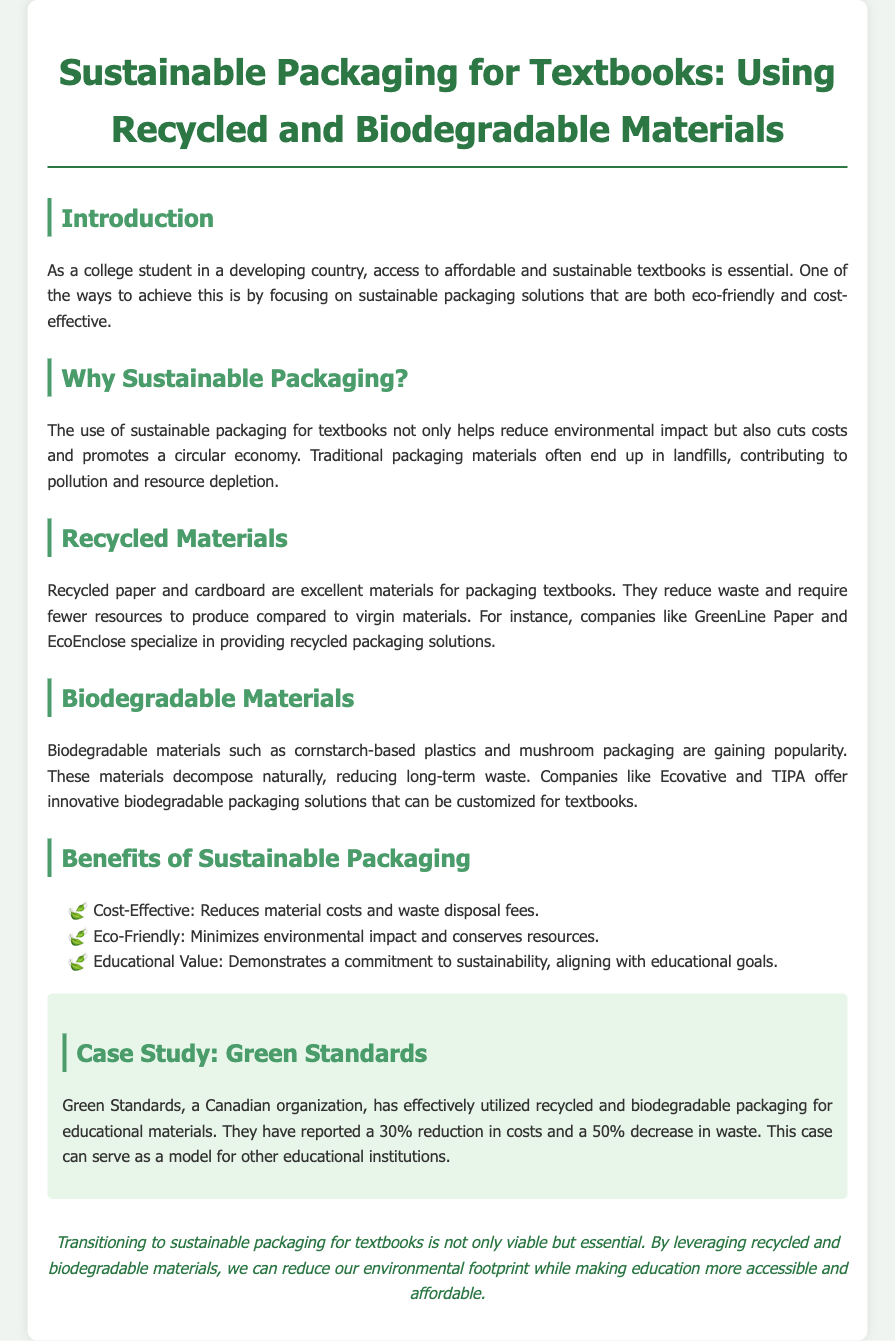What is the focus of the document? The document centers on sustainable packaging for textbooks, specifically using recycled and biodegradable materials.
Answer: Sustainable packaging for textbooks What is a major reason for using sustainable packaging? The document states that sustainable packaging helps reduce environmental impact and promotes a circular economy.
Answer: Reduce environmental impact Which company specializes in recycled packaging solutions? GreenLine Paper is mentioned as a company specializing in recycled packaging solutions.
Answer: GreenLine Paper What percentage reduction in costs did Green Standards report? Green Standards reported a 30% reduction in costs by utilizing sustainable packaging.
Answer: 30% What type of biodegradable material is gaining popularity? Cornstarch-based plastics are highlighted as a popular biodegradable material for packaging.
Answer: Cornstarch-based plastics What is one educational benefit of sustainable packaging mentioned? The document mentions that sustainable packaging demonstrates a commitment to sustainability, aligning with educational goals.
Answer: Commitment to sustainability What type of organization is Green Standards? Green Standards is referred to as a Canadian organization in the document.
Answer: Canadian organization How much waste reduction did Green Standards achieve? Green Standards reported a 50% decrease in waste as a result of using sustainable packaging.
Answer: 50% 